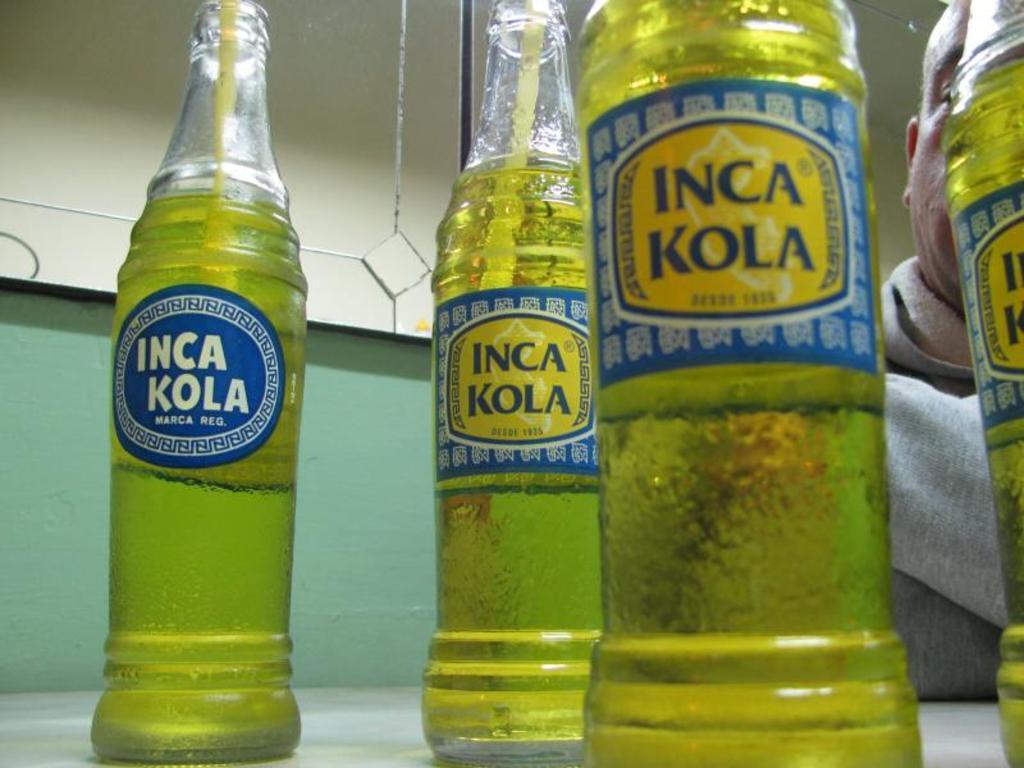What is that drink?
Your response must be concise. Inca kola. What is the brand name?
Provide a succinct answer. Inca kola. 